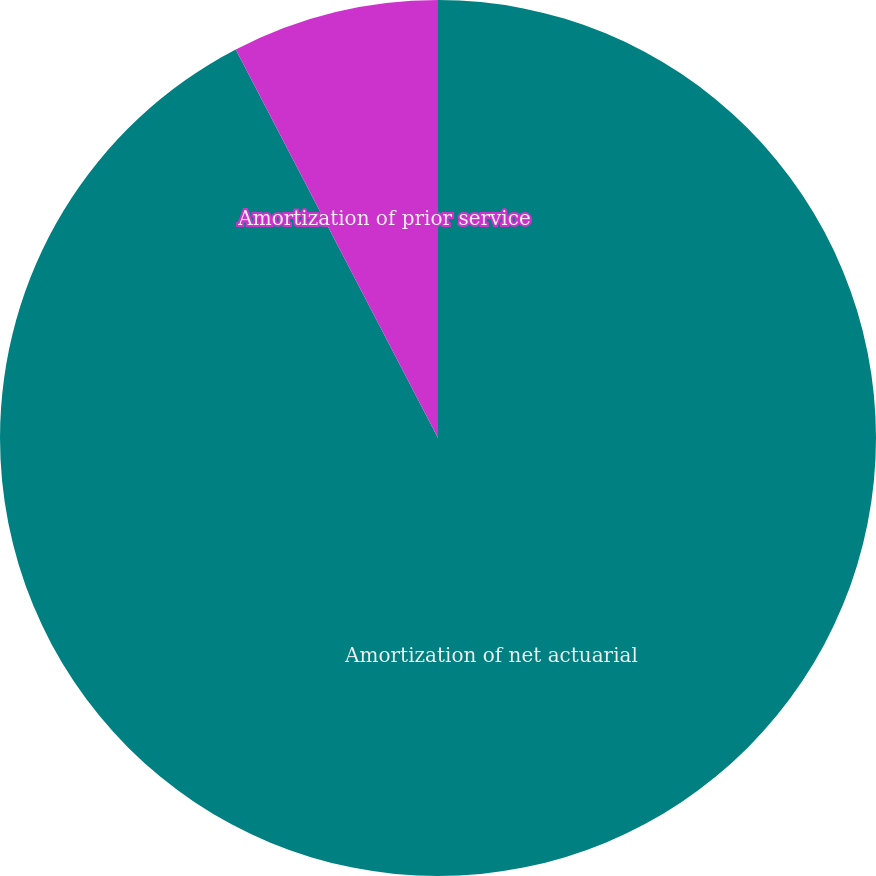Convert chart to OTSL. <chart><loc_0><loc_0><loc_500><loc_500><pie_chart><fcel>Amortization of net actuarial<fcel>Amortization of prior service<nl><fcel>92.36%<fcel>7.64%<nl></chart> 